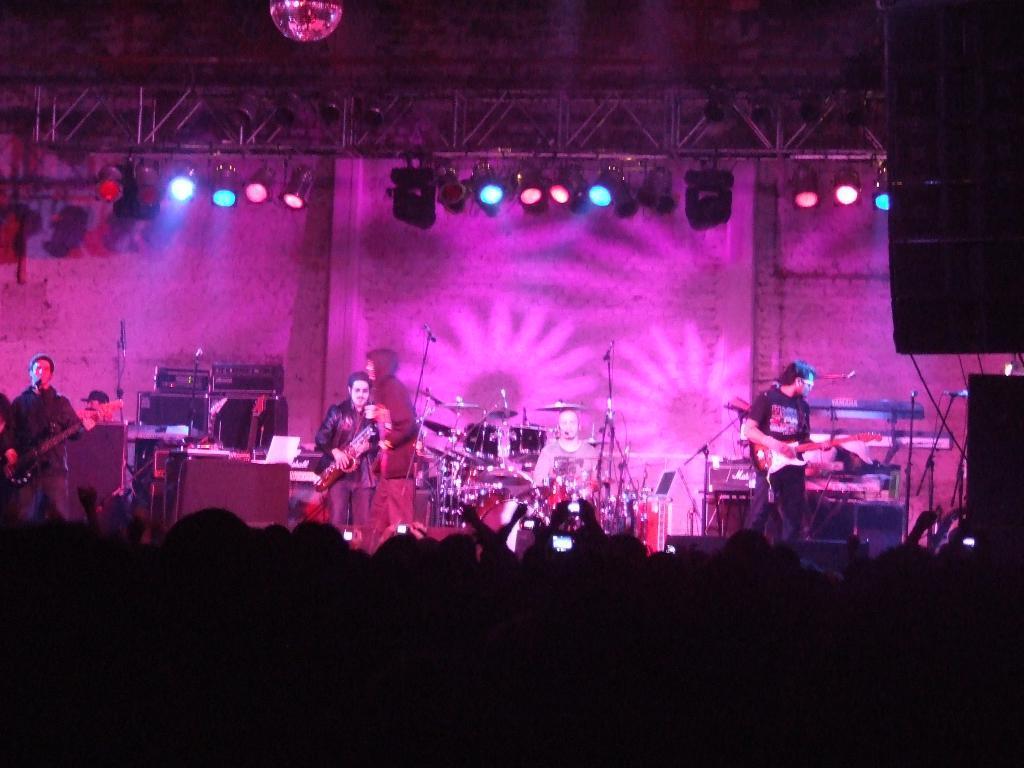How would you summarize this image in a sentence or two? In this picture we can see group of people standing and listening to the musicians were on stage we can see person playing guitar and singing on mic and in background we can see wall, lights, steel rods. 